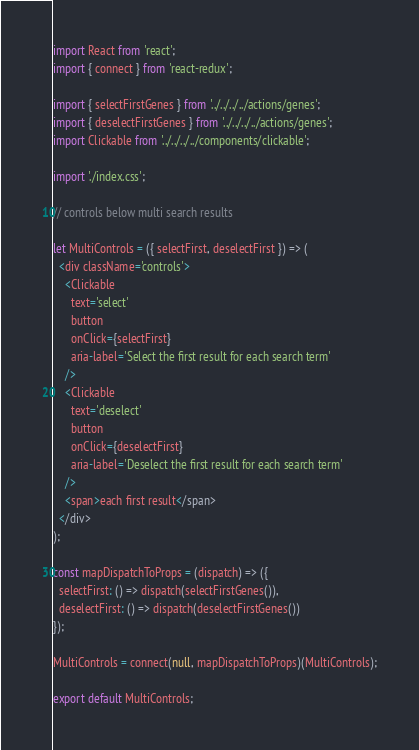Convert code to text. <code><loc_0><loc_0><loc_500><loc_500><_JavaScript_>import React from 'react';
import { connect } from 'react-redux';

import { selectFirstGenes } from '../../../../actions/genes';
import { deselectFirstGenes } from '../../../../actions/genes';
import Clickable from '../../../../components/clickable';

import './index.css';

// controls below multi search results

let MultiControls = ({ selectFirst, deselectFirst }) => (
  <div className='controls'>
    <Clickable
      text='select'
      button
      onClick={selectFirst}
      aria-label='Select the first result for each search term'
    />
    <Clickable
      text='deselect'
      button
      onClick={deselectFirst}
      aria-label='Deselect the first result for each search term'
    />
    <span>each first result</span>
  </div>
);

const mapDispatchToProps = (dispatch) => ({
  selectFirst: () => dispatch(selectFirstGenes()),
  deselectFirst: () => dispatch(deselectFirstGenes())
});

MultiControls = connect(null, mapDispatchToProps)(MultiControls);

export default MultiControls;
</code> 